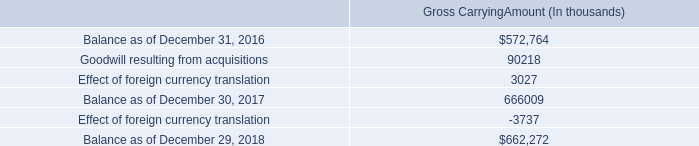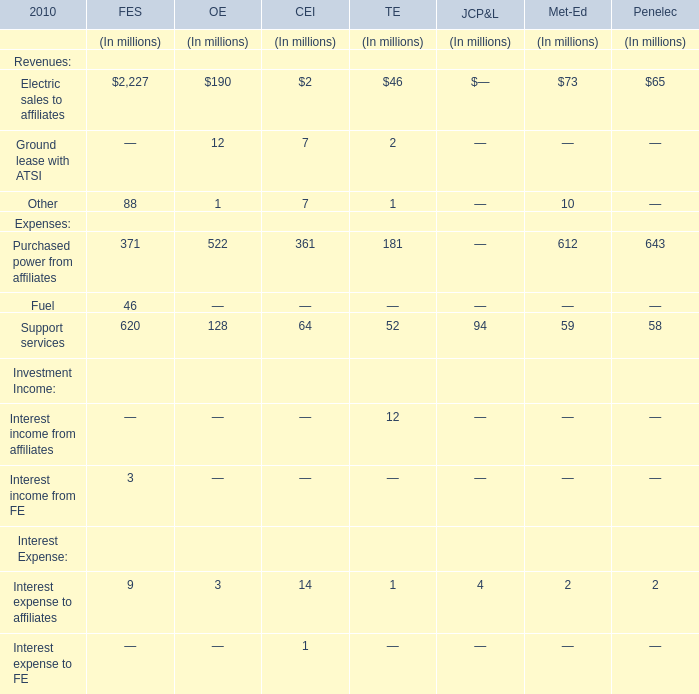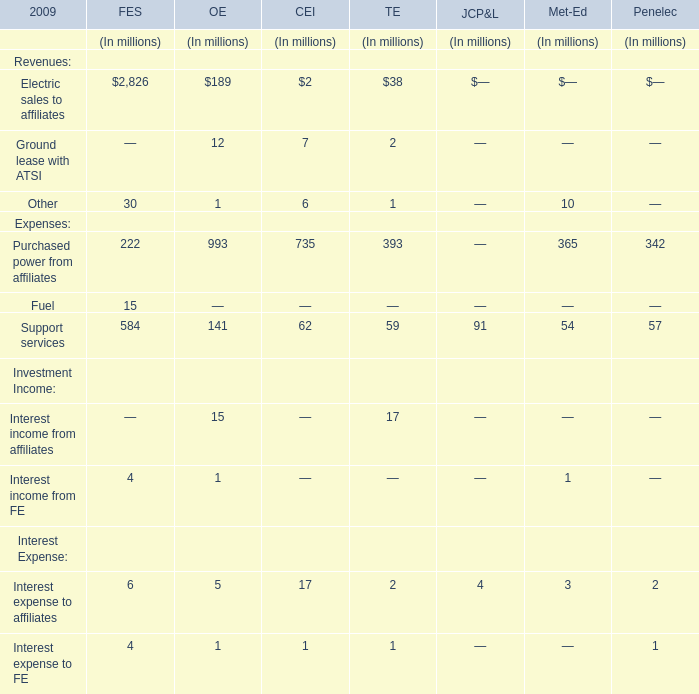what is the percentage increase in the balance of goodwill from 2017 to 2018? 
Computations: ((662272 - 666009) / 666009)
Answer: -0.00561. 